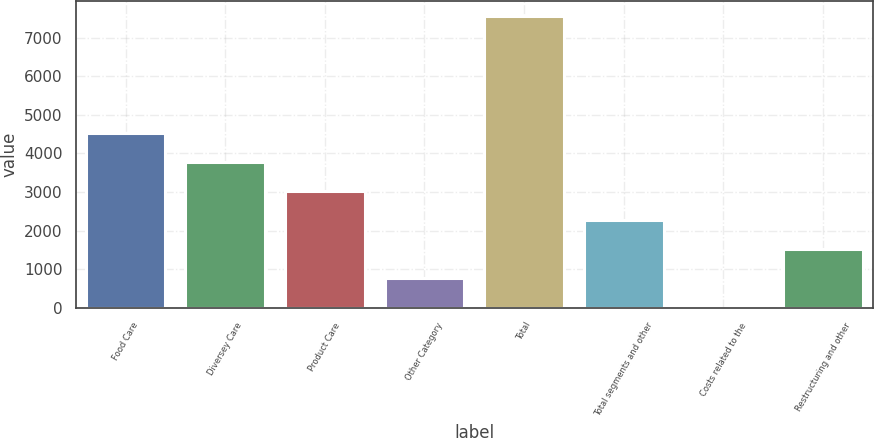<chart> <loc_0><loc_0><loc_500><loc_500><bar_chart><fcel>Food Care<fcel>Diversey Care<fcel>Product Care<fcel>Other Category<fcel>Total<fcel>Total segments and other<fcel>Costs related to the<fcel>Restructuring and other<nl><fcel>4538.48<fcel>3783.3<fcel>3028.12<fcel>762.58<fcel>7559.2<fcel>2272.94<fcel>7.4<fcel>1517.76<nl></chart> 